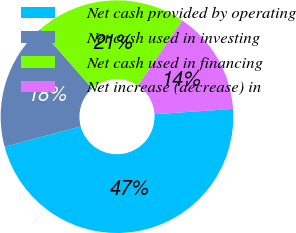Convert chart. <chart><loc_0><loc_0><loc_500><loc_500><pie_chart><fcel>Net cash provided by operating<fcel>Net cash used in investing<fcel>Net cash used in financing<fcel>Net increase (decrease) in<nl><fcel>46.9%<fcel>17.7%<fcel>20.94%<fcel>14.46%<nl></chart> 